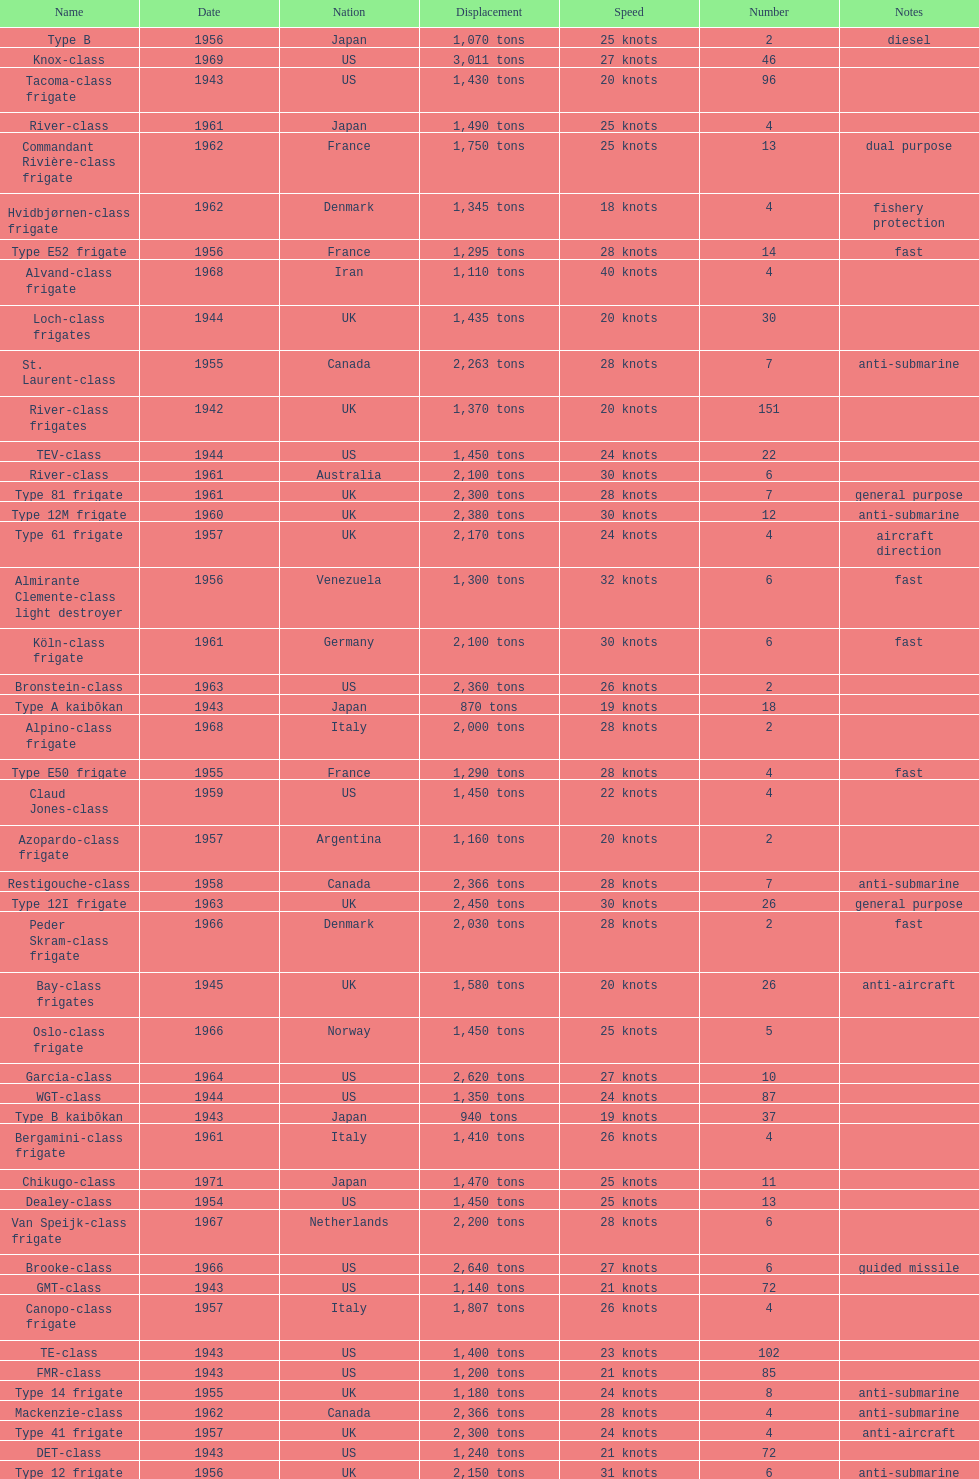What was the count of consecutive escorts in the year 1943? 7. 